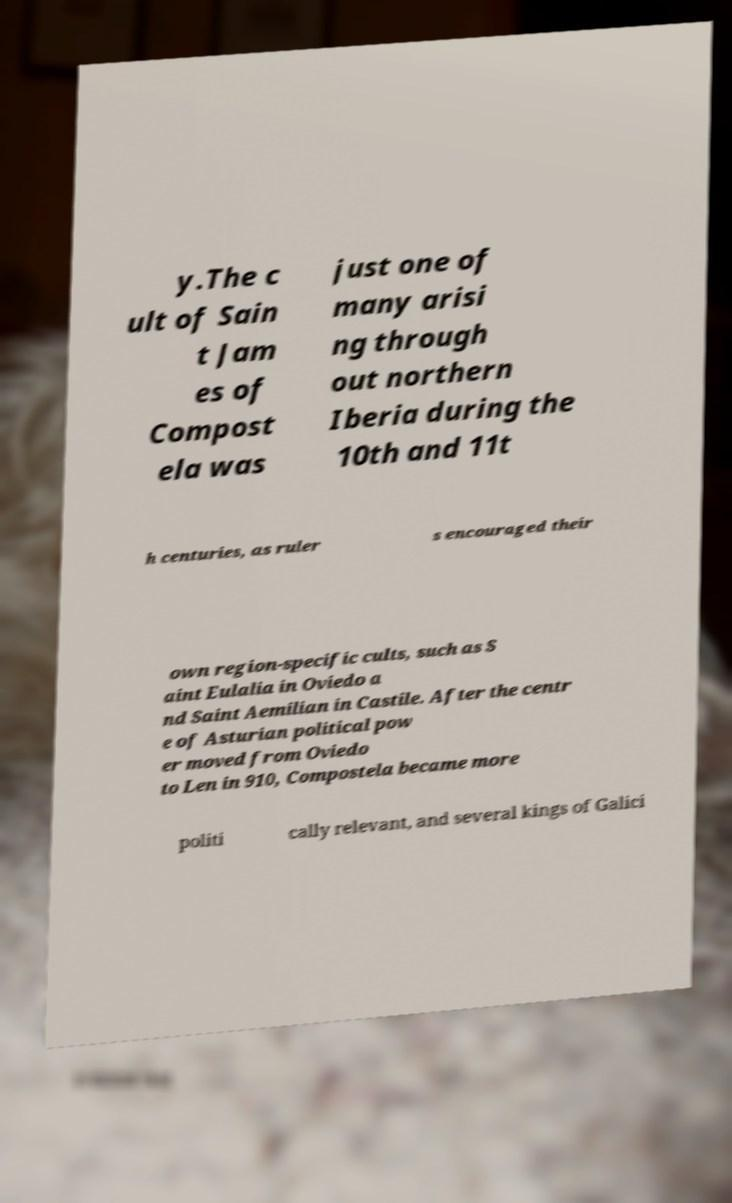For documentation purposes, I need the text within this image transcribed. Could you provide that? y.The c ult of Sain t Jam es of Compost ela was just one of many arisi ng through out northern Iberia during the 10th and 11t h centuries, as ruler s encouraged their own region-specific cults, such as S aint Eulalia in Oviedo a nd Saint Aemilian in Castile. After the centr e of Asturian political pow er moved from Oviedo to Len in 910, Compostela became more politi cally relevant, and several kings of Galici 